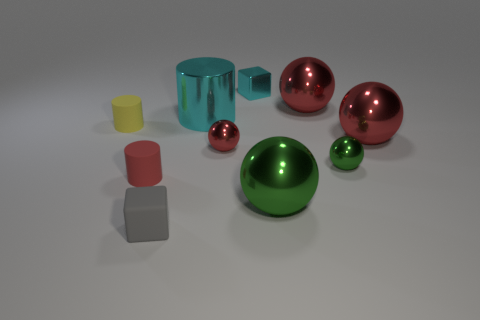Subtract all yellow matte cylinders. How many cylinders are left? 2 Subtract all yellow cubes. How many green spheres are left? 2 Subtract 1 cylinders. How many cylinders are left? 2 Subtract all green spheres. How many spheres are left? 3 Subtract all green balls. Subtract all red blocks. How many balls are left? 3 Subtract all blocks. How many objects are left? 8 Subtract all cyan metal things. Subtract all tiny rubber cylinders. How many objects are left? 6 Add 2 small red metallic objects. How many small red metallic objects are left? 3 Add 8 small blue balls. How many small blue balls exist? 8 Subtract 1 red balls. How many objects are left? 9 